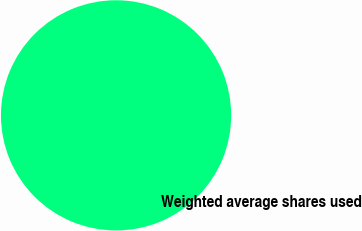<chart> <loc_0><loc_0><loc_500><loc_500><pie_chart><fcel>Weighted average shares used<nl><fcel>100.0%<nl></chart> 